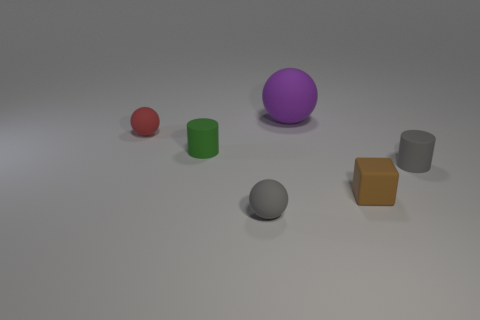The big ball that is the same material as the small brown block is what color?
Make the answer very short. Purple. Are there any gray rubber spheres of the same size as the purple rubber object?
Make the answer very short. No. There is another object that is the same shape as the green thing; what material is it?
Offer a terse response. Rubber. What is the shape of the red thing that is the same size as the green cylinder?
Ensure brevity in your answer.  Sphere. Is there a small object that has the same shape as the large purple rubber thing?
Make the answer very short. Yes. What is the shape of the matte thing on the left side of the rubber cylinder on the left side of the tiny brown cube?
Give a very brief answer. Sphere. What shape is the large matte thing?
Your answer should be very brief. Sphere. How many other things are there of the same material as the gray cylinder?
Offer a terse response. 5. What number of matte spheres are right of the gray rubber thing that is in front of the tiny brown matte cube?
Offer a very short reply. 1. What number of blocks are small things or red objects?
Your response must be concise. 1. 